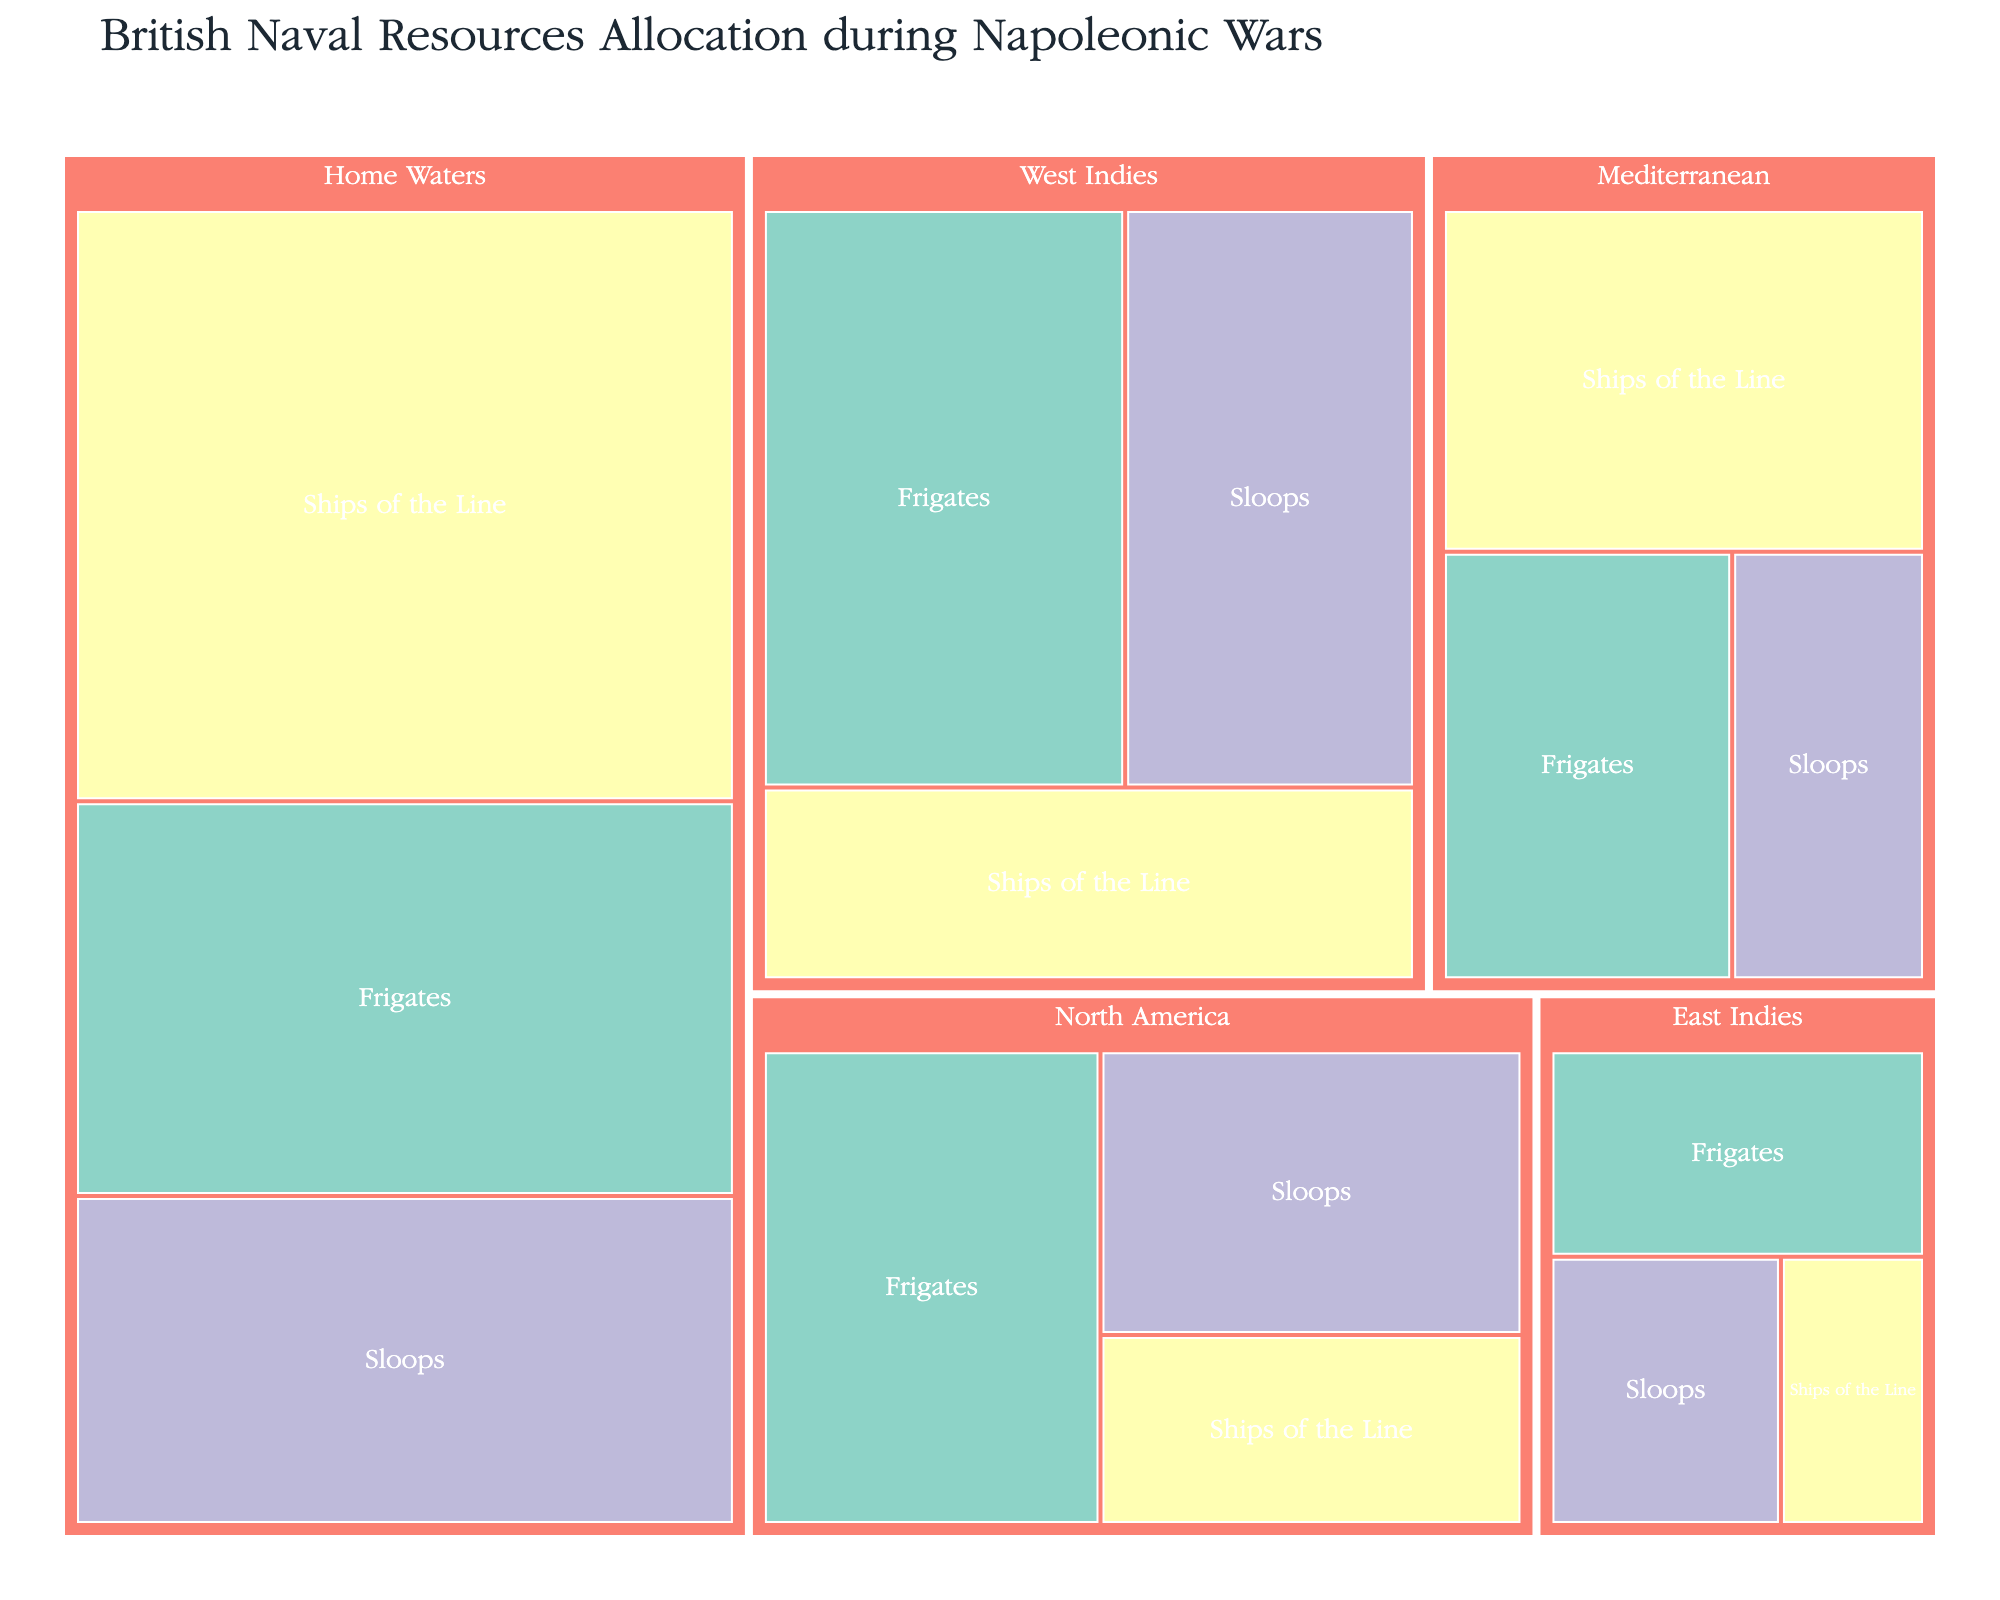What's the title of the figure? The title is usually displayed at the top of the figure, and it's clearly visible. For a treemap visualizing British Naval Resources Allocation, the title indicates the content being visualized.
Answer: British Naval Resources Allocation during Napoleonic Wars Which category has the most ships in Home Waters? By looking at the Home Waters section of the treemap, observe the size of the areas representing different categories. The largest section corresponds to the category with the most ships.
Answer: Ships of the Line How many frigates are there in the Mediterranean? Find the Mediterranean section in the treemap and look for the area representing frigates. The number of ships will be labeled.
Answer: 15 Which theatre has the largest total number of ships? To determine this, sum up the ships in each theatre section, and compare the totals. Home Waters has the largest sum because it includes 45 (Ships of the Line) + 30 (Frigates) + 25 (Sloops).
Answer: Home Waters What's the difference in the number of ships between the East Indies and North America? Calculate the total ships in both theatres: East Indies (5 + 10 + 8 = 23) and North America (10 + 20 + 15 = 45). Subtract the totals to find the difference.
Answer: 22 Which category has equal numbers of ships in both the West Indies and North America? Look at the treemap sections for West Indies and North America, and compare the number of ships in each category. Frigates have equal numbers in both theatres.
Answer: Frigates How many more ships of the line are allocated to Home Waters compared to the Mediterranean? Look at the sections for Ships of the Line in both Home Waters and the Mediterranean, and subtract the Mediterranean's number from Home Waters'.
Answer: 25 What is the average number of sloops across all theatres? Find the number of sloops in each theatre, sum them up (25 + 10 + 20 + 15 + 8 = 78), then divide by the number of theatres (5).
Answer: 15.6 Which theatre has the fewest total ships? Compute the total ships in each theatre and compare. The East Indies, with 5 + 10 + 8 = 23, has the fewest total ships.
Answer: East Indies What's the ratio of frigates to ships of the line in the West Indies? Find the number of frigates (25) and ships of the line (15) in the West Indies, then divide the number of frigates by the number of ships of the line.
Answer: 5:3 